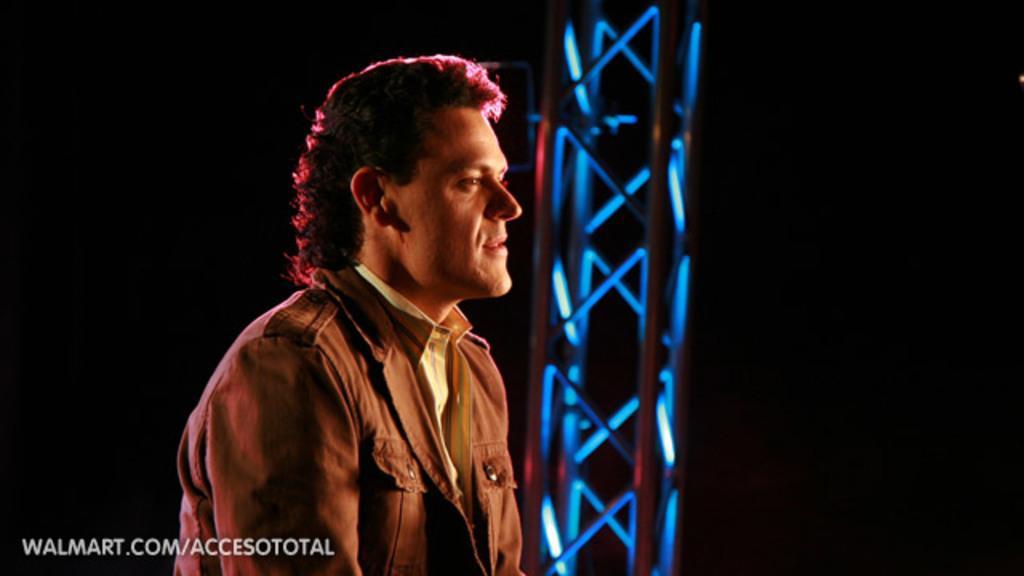Can you describe this image briefly? In this image we can see a person wearing a dress. To the right side of the image we can see a metal frame. In the bottom we can see some text. 